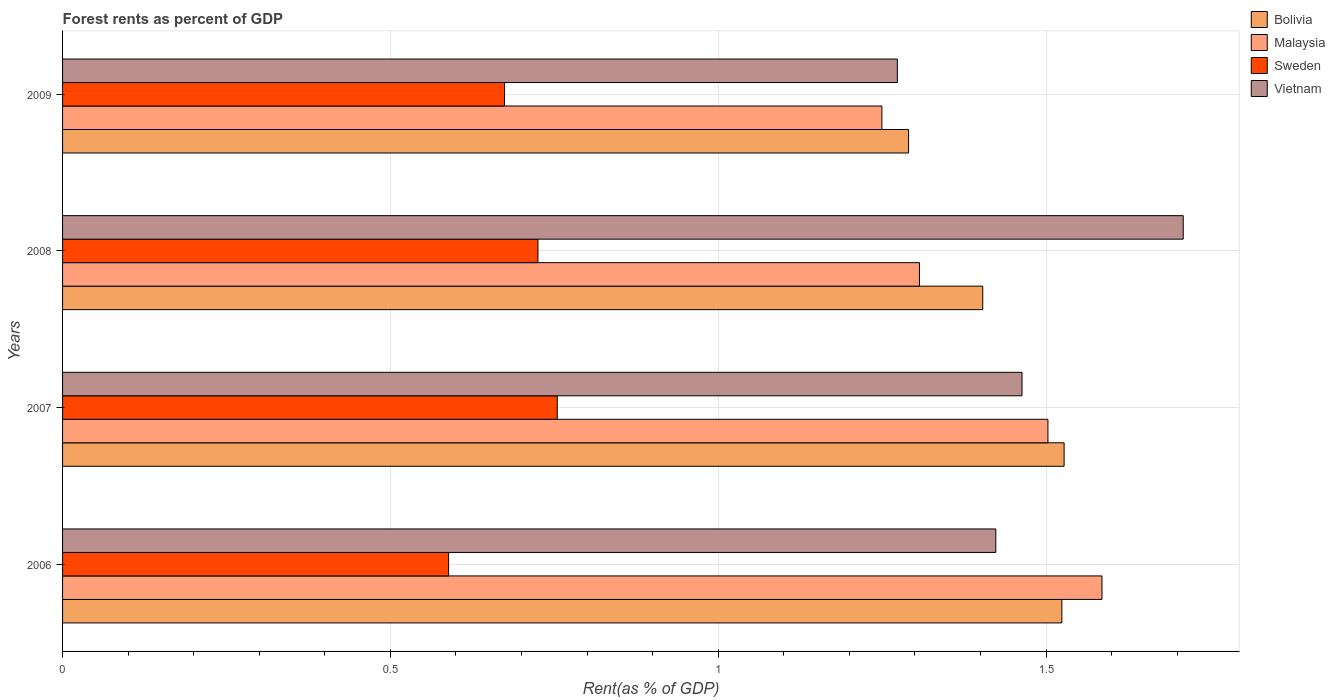How many groups of bars are there?
Your response must be concise. 4. Are the number of bars per tick equal to the number of legend labels?
Your answer should be very brief. Yes. Are the number of bars on each tick of the Y-axis equal?
Offer a terse response. Yes. How many bars are there on the 1st tick from the top?
Provide a short and direct response. 4. In how many cases, is the number of bars for a given year not equal to the number of legend labels?
Keep it short and to the point. 0. What is the forest rent in Bolivia in 2009?
Provide a short and direct response. 1.29. Across all years, what is the maximum forest rent in Sweden?
Offer a very short reply. 0.75. Across all years, what is the minimum forest rent in Malaysia?
Provide a succinct answer. 1.25. In which year was the forest rent in Sweden minimum?
Keep it short and to the point. 2006. What is the total forest rent in Sweden in the graph?
Your answer should be very brief. 2.74. What is the difference between the forest rent in Malaysia in 2006 and that in 2009?
Give a very brief answer. 0.34. What is the difference between the forest rent in Vietnam in 2006 and the forest rent in Malaysia in 2008?
Your answer should be compact. 0.12. What is the average forest rent in Sweden per year?
Make the answer very short. 0.69. In the year 2008, what is the difference between the forest rent in Sweden and forest rent in Vietnam?
Offer a very short reply. -0.98. What is the ratio of the forest rent in Bolivia in 2006 to that in 2008?
Give a very brief answer. 1.09. What is the difference between the highest and the second highest forest rent in Sweden?
Ensure brevity in your answer.  0.03. What is the difference between the highest and the lowest forest rent in Sweden?
Offer a very short reply. 0.17. In how many years, is the forest rent in Sweden greater than the average forest rent in Sweden taken over all years?
Ensure brevity in your answer.  2. Is it the case that in every year, the sum of the forest rent in Sweden and forest rent in Malaysia is greater than the sum of forest rent in Bolivia and forest rent in Vietnam?
Your response must be concise. No. What does the 3rd bar from the top in 2006 represents?
Give a very brief answer. Malaysia. How many bars are there?
Keep it short and to the point. 16. How many years are there in the graph?
Offer a very short reply. 4. How many legend labels are there?
Provide a succinct answer. 4. How are the legend labels stacked?
Keep it short and to the point. Vertical. What is the title of the graph?
Your answer should be very brief. Forest rents as percent of GDP. Does "Honduras" appear as one of the legend labels in the graph?
Your response must be concise. No. What is the label or title of the X-axis?
Your answer should be very brief. Rent(as % of GDP). What is the label or title of the Y-axis?
Make the answer very short. Years. What is the Rent(as % of GDP) in Bolivia in 2006?
Provide a succinct answer. 1.52. What is the Rent(as % of GDP) of Malaysia in 2006?
Your response must be concise. 1.59. What is the Rent(as % of GDP) of Sweden in 2006?
Ensure brevity in your answer.  0.59. What is the Rent(as % of GDP) in Vietnam in 2006?
Ensure brevity in your answer.  1.42. What is the Rent(as % of GDP) of Bolivia in 2007?
Offer a very short reply. 1.53. What is the Rent(as % of GDP) in Malaysia in 2007?
Give a very brief answer. 1.5. What is the Rent(as % of GDP) in Sweden in 2007?
Make the answer very short. 0.75. What is the Rent(as % of GDP) in Vietnam in 2007?
Provide a succinct answer. 1.46. What is the Rent(as % of GDP) in Bolivia in 2008?
Your response must be concise. 1.4. What is the Rent(as % of GDP) in Malaysia in 2008?
Ensure brevity in your answer.  1.31. What is the Rent(as % of GDP) of Sweden in 2008?
Offer a very short reply. 0.73. What is the Rent(as % of GDP) in Vietnam in 2008?
Offer a very short reply. 1.71. What is the Rent(as % of GDP) of Bolivia in 2009?
Provide a short and direct response. 1.29. What is the Rent(as % of GDP) in Malaysia in 2009?
Ensure brevity in your answer.  1.25. What is the Rent(as % of GDP) in Sweden in 2009?
Give a very brief answer. 0.67. What is the Rent(as % of GDP) of Vietnam in 2009?
Your answer should be very brief. 1.27. Across all years, what is the maximum Rent(as % of GDP) of Bolivia?
Provide a short and direct response. 1.53. Across all years, what is the maximum Rent(as % of GDP) in Malaysia?
Your response must be concise. 1.59. Across all years, what is the maximum Rent(as % of GDP) in Sweden?
Provide a short and direct response. 0.75. Across all years, what is the maximum Rent(as % of GDP) of Vietnam?
Give a very brief answer. 1.71. Across all years, what is the minimum Rent(as % of GDP) in Bolivia?
Your answer should be compact. 1.29. Across all years, what is the minimum Rent(as % of GDP) in Malaysia?
Keep it short and to the point. 1.25. Across all years, what is the minimum Rent(as % of GDP) of Sweden?
Ensure brevity in your answer.  0.59. Across all years, what is the minimum Rent(as % of GDP) of Vietnam?
Your answer should be compact. 1.27. What is the total Rent(as % of GDP) of Bolivia in the graph?
Provide a succinct answer. 5.75. What is the total Rent(as % of GDP) in Malaysia in the graph?
Your response must be concise. 5.64. What is the total Rent(as % of GDP) in Sweden in the graph?
Your answer should be very brief. 2.74. What is the total Rent(as % of GDP) in Vietnam in the graph?
Offer a terse response. 5.87. What is the difference between the Rent(as % of GDP) of Bolivia in 2006 and that in 2007?
Your answer should be very brief. -0. What is the difference between the Rent(as % of GDP) of Malaysia in 2006 and that in 2007?
Provide a succinct answer. 0.08. What is the difference between the Rent(as % of GDP) in Sweden in 2006 and that in 2007?
Make the answer very short. -0.17. What is the difference between the Rent(as % of GDP) of Vietnam in 2006 and that in 2007?
Your response must be concise. -0.04. What is the difference between the Rent(as % of GDP) in Bolivia in 2006 and that in 2008?
Give a very brief answer. 0.12. What is the difference between the Rent(as % of GDP) in Malaysia in 2006 and that in 2008?
Keep it short and to the point. 0.28. What is the difference between the Rent(as % of GDP) of Sweden in 2006 and that in 2008?
Keep it short and to the point. -0.14. What is the difference between the Rent(as % of GDP) of Vietnam in 2006 and that in 2008?
Your answer should be compact. -0.29. What is the difference between the Rent(as % of GDP) in Bolivia in 2006 and that in 2009?
Provide a short and direct response. 0.23. What is the difference between the Rent(as % of GDP) in Malaysia in 2006 and that in 2009?
Ensure brevity in your answer.  0.34. What is the difference between the Rent(as % of GDP) in Sweden in 2006 and that in 2009?
Provide a short and direct response. -0.09. What is the difference between the Rent(as % of GDP) of Vietnam in 2006 and that in 2009?
Make the answer very short. 0.15. What is the difference between the Rent(as % of GDP) of Bolivia in 2007 and that in 2008?
Make the answer very short. 0.12. What is the difference between the Rent(as % of GDP) in Malaysia in 2007 and that in 2008?
Your answer should be very brief. 0.2. What is the difference between the Rent(as % of GDP) in Sweden in 2007 and that in 2008?
Provide a succinct answer. 0.03. What is the difference between the Rent(as % of GDP) of Vietnam in 2007 and that in 2008?
Your answer should be compact. -0.25. What is the difference between the Rent(as % of GDP) in Bolivia in 2007 and that in 2009?
Offer a terse response. 0.24. What is the difference between the Rent(as % of GDP) of Malaysia in 2007 and that in 2009?
Keep it short and to the point. 0.25. What is the difference between the Rent(as % of GDP) of Sweden in 2007 and that in 2009?
Your answer should be compact. 0.08. What is the difference between the Rent(as % of GDP) in Vietnam in 2007 and that in 2009?
Your answer should be very brief. 0.19. What is the difference between the Rent(as % of GDP) in Bolivia in 2008 and that in 2009?
Give a very brief answer. 0.11. What is the difference between the Rent(as % of GDP) in Malaysia in 2008 and that in 2009?
Your response must be concise. 0.06. What is the difference between the Rent(as % of GDP) in Sweden in 2008 and that in 2009?
Give a very brief answer. 0.05. What is the difference between the Rent(as % of GDP) of Vietnam in 2008 and that in 2009?
Your response must be concise. 0.44. What is the difference between the Rent(as % of GDP) of Bolivia in 2006 and the Rent(as % of GDP) of Malaysia in 2007?
Your answer should be compact. 0.02. What is the difference between the Rent(as % of GDP) of Bolivia in 2006 and the Rent(as % of GDP) of Sweden in 2007?
Your answer should be very brief. 0.77. What is the difference between the Rent(as % of GDP) in Bolivia in 2006 and the Rent(as % of GDP) in Vietnam in 2007?
Provide a short and direct response. 0.06. What is the difference between the Rent(as % of GDP) in Malaysia in 2006 and the Rent(as % of GDP) in Sweden in 2007?
Your answer should be very brief. 0.83. What is the difference between the Rent(as % of GDP) of Malaysia in 2006 and the Rent(as % of GDP) of Vietnam in 2007?
Your response must be concise. 0.12. What is the difference between the Rent(as % of GDP) of Sweden in 2006 and the Rent(as % of GDP) of Vietnam in 2007?
Your answer should be very brief. -0.87. What is the difference between the Rent(as % of GDP) in Bolivia in 2006 and the Rent(as % of GDP) in Malaysia in 2008?
Give a very brief answer. 0.22. What is the difference between the Rent(as % of GDP) in Bolivia in 2006 and the Rent(as % of GDP) in Sweden in 2008?
Ensure brevity in your answer.  0.8. What is the difference between the Rent(as % of GDP) in Bolivia in 2006 and the Rent(as % of GDP) in Vietnam in 2008?
Make the answer very short. -0.19. What is the difference between the Rent(as % of GDP) in Malaysia in 2006 and the Rent(as % of GDP) in Sweden in 2008?
Provide a succinct answer. 0.86. What is the difference between the Rent(as % of GDP) of Malaysia in 2006 and the Rent(as % of GDP) of Vietnam in 2008?
Provide a succinct answer. -0.12. What is the difference between the Rent(as % of GDP) of Sweden in 2006 and the Rent(as % of GDP) of Vietnam in 2008?
Ensure brevity in your answer.  -1.12. What is the difference between the Rent(as % of GDP) of Bolivia in 2006 and the Rent(as % of GDP) of Malaysia in 2009?
Your answer should be very brief. 0.27. What is the difference between the Rent(as % of GDP) of Bolivia in 2006 and the Rent(as % of GDP) of Vietnam in 2009?
Give a very brief answer. 0.25. What is the difference between the Rent(as % of GDP) of Malaysia in 2006 and the Rent(as % of GDP) of Sweden in 2009?
Your answer should be compact. 0.91. What is the difference between the Rent(as % of GDP) in Malaysia in 2006 and the Rent(as % of GDP) in Vietnam in 2009?
Your response must be concise. 0.31. What is the difference between the Rent(as % of GDP) of Sweden in 2006 and the Rent(as % of GDP) of Vietnam in 2009?
Keep it short and to the point. -0.68. What is the difference between the Rent(as % of GDP) of Bolivia in 2007 and the Rent(as % of GDP) of Malaysia in 2008?
Offer a terse response. 0.22. What is the difference between the Rent(as % of GDP) of Bolivia in 2007 and the Rent(as % of GDP) of Sweden in 2008?
Offer a very short reply. 0.8. What is the difference between the Rent(as % of GDP) in Bolivia in 2007 and the Rent(as % of GDP) in Vietnam in 2008?
Your answer should be compact. -0.18. What is the difference between the Rent(as % of GDP) in Malaysia in 2007 and the Rent(as % of GDP) in Vietnam in 2008?
Keep it short and to the point. -0.21. What is the difference between the Rent(as % of GDP) in Sweden in 2007 and the Rent(as % of GDP) in Vietnam in 2008?
Offer a very short reply. -0.95. What is the difference between the Rent(as % of GDP) of Bolivia in 2007 and the Rent(as % of GDP) of Malaysia in 2009?
Offer a very short reply. 0.28. What is the difference between the Rent(as % of GDP) of Bolivia in 2007 and the Rent(as % of GDP) of Sweden in 2009?
Your answer should be compact. 0.85. What is the difference between the Rent(as % of GDP) of Bolivia in 2007 and the Rent(as % of GDP) of Vietnam in 2009?
Your answer should be very brief. 0.25. What is the difference between the Rent(as % of GDP) of Malaysia in 2007 and the Rent(as % of GDP) of Sweden in 2009?
Provide a short and direct response. 0.83. What is the difference between the Rent(as % of GDP) in Malaysia in 2007 and the Rent(as % of GDP) in Vietnam in 2009?
Your response must be concise. 0.23. What is the difference between the Rent(as % of GDP) of Sweden in 2007 and the Rent(as % of GDP) of Vietnam in 2009?
Offer a terse response. -0.52. What is the difference between the Rent(as % of GDP) in Bolivia in 2008 and the Rent(as % of GDP) in Malaysia in 2009?
Give a very brief answer. 0.15. What is the difference between the Rent(as % of GDP) of Bolivia in 2008 and the Rent(as % of GDP) of Sweden in 2009?
Offer a terse response. 0.73. What is the difference between the Rent(as % of GDP) of Bolivia in 2008 and the Rent(as % of GDP) of Vietnam in 2009?
Your answer should be very brief. 0.13. What is the difference between the Rent(as % of GDP) in Malaysia in 2008 and the Rent(as % of GDP) in Sweden in 2009?
Ensure brevity in your answer.  0.63. What is the difference between the Rent(as % of GDP) of Malaysia in 2008 and the Rent(as % of GDP) of Vietnam in 2009?
Keep it short and to the point. 0.03. What is the difference between the Rent(as % of GDP) of Sweden in 2008 and the Rent(as % of GDP) of Vietnam in 2009?
Keep it short and to the point. -0.55. What is the average Rent(as % of GDP) of Bolivia per year?
Ensure brevity in your answer.  1.44. What is the average Rent(as % of GDP) in Malaysia per year?
Provide a short and direct response. 1.41. What is the average Rent(as % of GDP) in Sweden per year?
Keep it short and to the point. 0.69. What is the average Rent(as % of GDP) of Vietnam per year?
Provide a succinct answer. 1.47. In the year 2006, what is the difference between the Rent(as % of GDP) in Bolivia and Rent(as % of GDP) in Malaysia?
Provide a short and direct response. -0.06. In the year 2006, what is the difference between the Rent(as % of GDP) of Bolivia and Rent(as % of GDP) of Sweden?
Offer a very short reply. 0.94. In the year 2006, what is the difference between the Rent(as % of GDP) of Bolivia and Rent(as % of GDP) of Vietnam?
Offer a very short reply. 0.1. In the year 2006, what is the difference between the Rent(as % of GDP) of Malaysia and Rent(as % of GDP) of Vietnam?
Offer a terse response. 0.16. In the year 2006, what is the difference between the Rent(as % of GDP) of Sweden and Rent(as % of GDP) of Vietnam?
Offer a terse response. -0.83. In the year 2007, what is the difference between the Rent(as % of GDP) in Bolivia and Rent(as % of GDP) in Malaysia?
Your answer should be compact. 0.02. In the year 2007, what is the difference between the Rent(as % of GDP) of Bolivia and Rent(as % of GDP) of Sweden?
Keep it short and to the point. 0.77. In the year 2007, what is the difference between the Rent(as % of GDP) of Bolivia and Rent(as % of GDP) of Vietnam?
Offer a very short reply. 0.06. In the year 2007, what is the difference between the Rent(as % of GDP) in Malaysia and Rent(as % of GDP) in Sweden?
Offer a terse response. 0.75. In the year 2007, what is the difference between the Rent(as % of GDP) in Malaysia and Rent(as % of GDP) in Vietnam?
Give a very brief answer. 0.04. In the year 2007, what is the difference between the Rent(as % of GDP) of Sweden and Rent(as % of GDP) of Vietnam?
Offer a very short reply. -0.71. In the year 2008, what is the difference between the Rent(as % of GDP) in Bolivia and Rent(as % of GDP) in Malaysia?
Provide a short and direct response. 0.1. In the year 2008, what is the difference between the Rent(as % of GDP) of Bolivia and Rent(as % of GDP) of Sweden?
Make the answer very short. 0.68. In the year 2008, what is the difference between the Rent(as % of GDP) of Bolivia and Rent(as % of GDP) of Vietnam?
Your answer should be compact. -0.31. In the year 2008, what is the difference between the Rent(as % of GDP) in Malaysia and Rent(as % of GDP) in Sweden?
Provide a short and direct response. 0.58. In the year 2008, what is the difference between the Rent(as % of GDP) in Malaysia and Rent(as % of GDP) in Vietnam?
Make the answer very short. -0.4. In the year 2008, what is the difference between the Rent(as % of GDP) in Sweden and Rent(as % of GDP) in Vietnam?
Offer a very short reply. -0.98. In the year 2009, what is the difference between the Rent(as % of GDP) in Bolivia and Rent(as % of GDP) in Malaysia?
Provide a short and direct response. 0.04. In the year 2009, what is the difference between the Rent(as % of GDP) in Bolivia and Rent(as % of GDP) in Sweden?
Give a very brief answer. 0.62. In the year 2009, what is the difference between the Rent(as % of GDP) of Bolivia and Rent(as % of GDP) of Vietnam?
Your response must be concise. 0.02. In the year 2009, what is the difference between the Rent(as % of GDP) of Malaysia and Rent(as % of GDP) of Sweden?
Give a very brief answer. 0.58. In the year 2009, what is the difference between the Rent(as % of GDP) in Malaysia and Rent(as % of GDP) in Vietnam?
Give a very brief answer. -0.02. In the year 2009, what is the difference between the Rent(as % of GDP) of Sweden and Rent(as % of GDP) of Vietnam?
Make the answer very short. -0.6. What is the ratio of the Rent(as % of GDP) of Bolivia in 2006 to that in 2007?
Ensure brevity in your answer.  1. What is the ratio of the Rent(as % of GDP) of Malaysia in 2006 to that in 2007?
Keep it short and to the point. 1.05. What is the ratio of the Rent(as % of GDP) of Sweden in 2006 to that in 2007?
Provide a short and direct response. 0.78. What is the ratio of the Rent(as % of GDP) in Vietnam in 2006 to that in 2007?
Your answer should be compact. 0.97. What is the ratio of the Rent(as % of GDP) in Bolivia in 2006 to that in 2008?
Ensure brevity in your answer.  1.09. What is the ratio of the Rent(as % of GDP) of Malaysia in 2006 to that in 2008?
Your answer should be very brief. 1.21. What is the ratio of the Rent(as % of GDP) in Sweden in 2006 to that in 2008?
Your answer should be compact. 0.81. What is the ratio of the Rent(as % of GDP) in Vietnam in 2006 to that in 2008?
Give a very brief answer. 0.83. What is the ratio of the Rent(as % of GDP) of Bolivia in 2006 to that in 2009?
Give a very brief answer. 1.18. What is the ratio of the Rent(as % of GDP) in Malaysia in 2006 to that in 2009?
Give a very brief answer. 1.27. What is the ratio of the Rent(as % of GDP) of Sweden in 2006 to that in 2009?
Your answer should be compact. 0.87. What is the ratio of the Rent(as % of GDP) of Vietnam in 2006 to that in 2009?
Offer a very short reply. 1.12. What is the ratio of the Rent(as % of GDP) of Bolivia in 2007 to that in 2008?
Ensure brevity in your answer.  1.09. What is the ratio of the Rent(as % of GDP) in Malaysia in 2007 to that in 2008?
Provide a succinct answer. 1.15. What is the ratio of the Rent(as % of GDP) in Sweden in 2007 to that in 2008?
Provide a succinct answer. 1.04. What is the ratio of the Rent(as % of GDP) of Vietnam in 2007 to that in 2008?
Your answer should be compact. 0.86. What is the ratio of the Rent(as % of GDP) of Bolivia in 2007 to that in 2009?
Your answer should be very brief. 1.18. What is the ratio of the Rent(as % of GDP) of Malaysia in 2007 to that in 2009?
Your answer should be compact. 1.2. What is the ratio of the Rent(as % of GDP) of Sweden in 2007 to that in 2009?
Your answer should be very brief. 1.12. What is the ratio of the Rent(as % of GDP) in Vietnam in 2007 to that in 2009?
Offer a very short reply. 1.15. What is the ratio of the Rent(as % of GDP) in Bolivia in 2008 to that in 2009?
Offer a terse response. 1.09. What is the ratio of the Rent(as % of GDP) of Malaysia in 2008 to that in 2009?
Make the answer very short. 1.05. What is the ratio of the Rent(as % of GDP) of Sweden in 2008 to that in 2009?
Provide a short and direct response. 1.08. What is the ratio of the Rent(as % of GDP) of Vietnam in 2008 to that in 2009?
Keep it short and to the point. 1.34. What is the difference between the highest and the second highest Rent(as % of GDP) in Bolivia?
Your answer should be very brief. 0. What is the difference between the highest and the second highest Rent(as % of GDP) of Malaysia?
Provide a short and direct response. 0.08. What is the difference between the highest and the second highest Rent(as % of GDP) in Sweden?
Provide a short and direct response. 0.03. What is the difference between the highest and the second highest Rent(as % of GDP) in Vietnam?
Your answer should be compact. 0.25. What is the difference between the highest and the lowest Rent(as % of GDP) of Bolivia?
Make the answer very short. 0.24. What is the difference between the highest and the lowest Rent(as % of GDP) in Malaysia?
Keep it short and to the point. 0.34. What is the difference between the highest and the lowest Rent(as % of GDP) in Sweden?
Give a very brief answer. 0.17. What is the difference between the highest and the lowest Rent(as % of GDP) of Vietnam?
Keep it short and to the point. 0.44. 